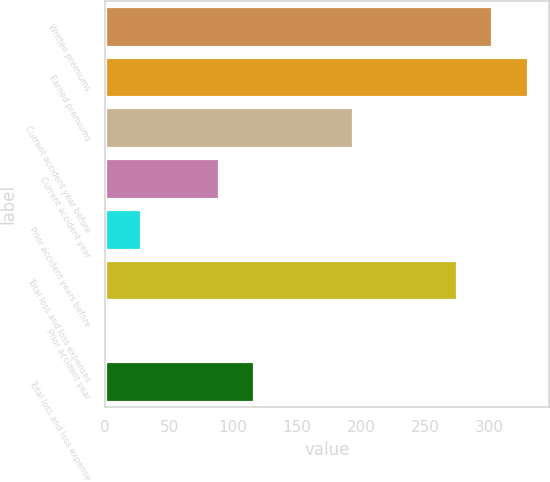Convert chart. <chart><loc_0><loc_0><loc_500><loc_500><bar_chart><fcel>Written premiums<fcel>Earned premiums<fcel>Current accident year before<fcel>Current accident year<fcel>Prior accident years before<fcel>Total loss and loss expenses<fcel>Prior accident year<fcel>Total loss and loss expense<nl><fcel>302.66<fcel>330.32<fcel>194<fcel>89<fcel>28.06<fcel>275<fcel>0.4<fcel>116.66<nl></chart> 